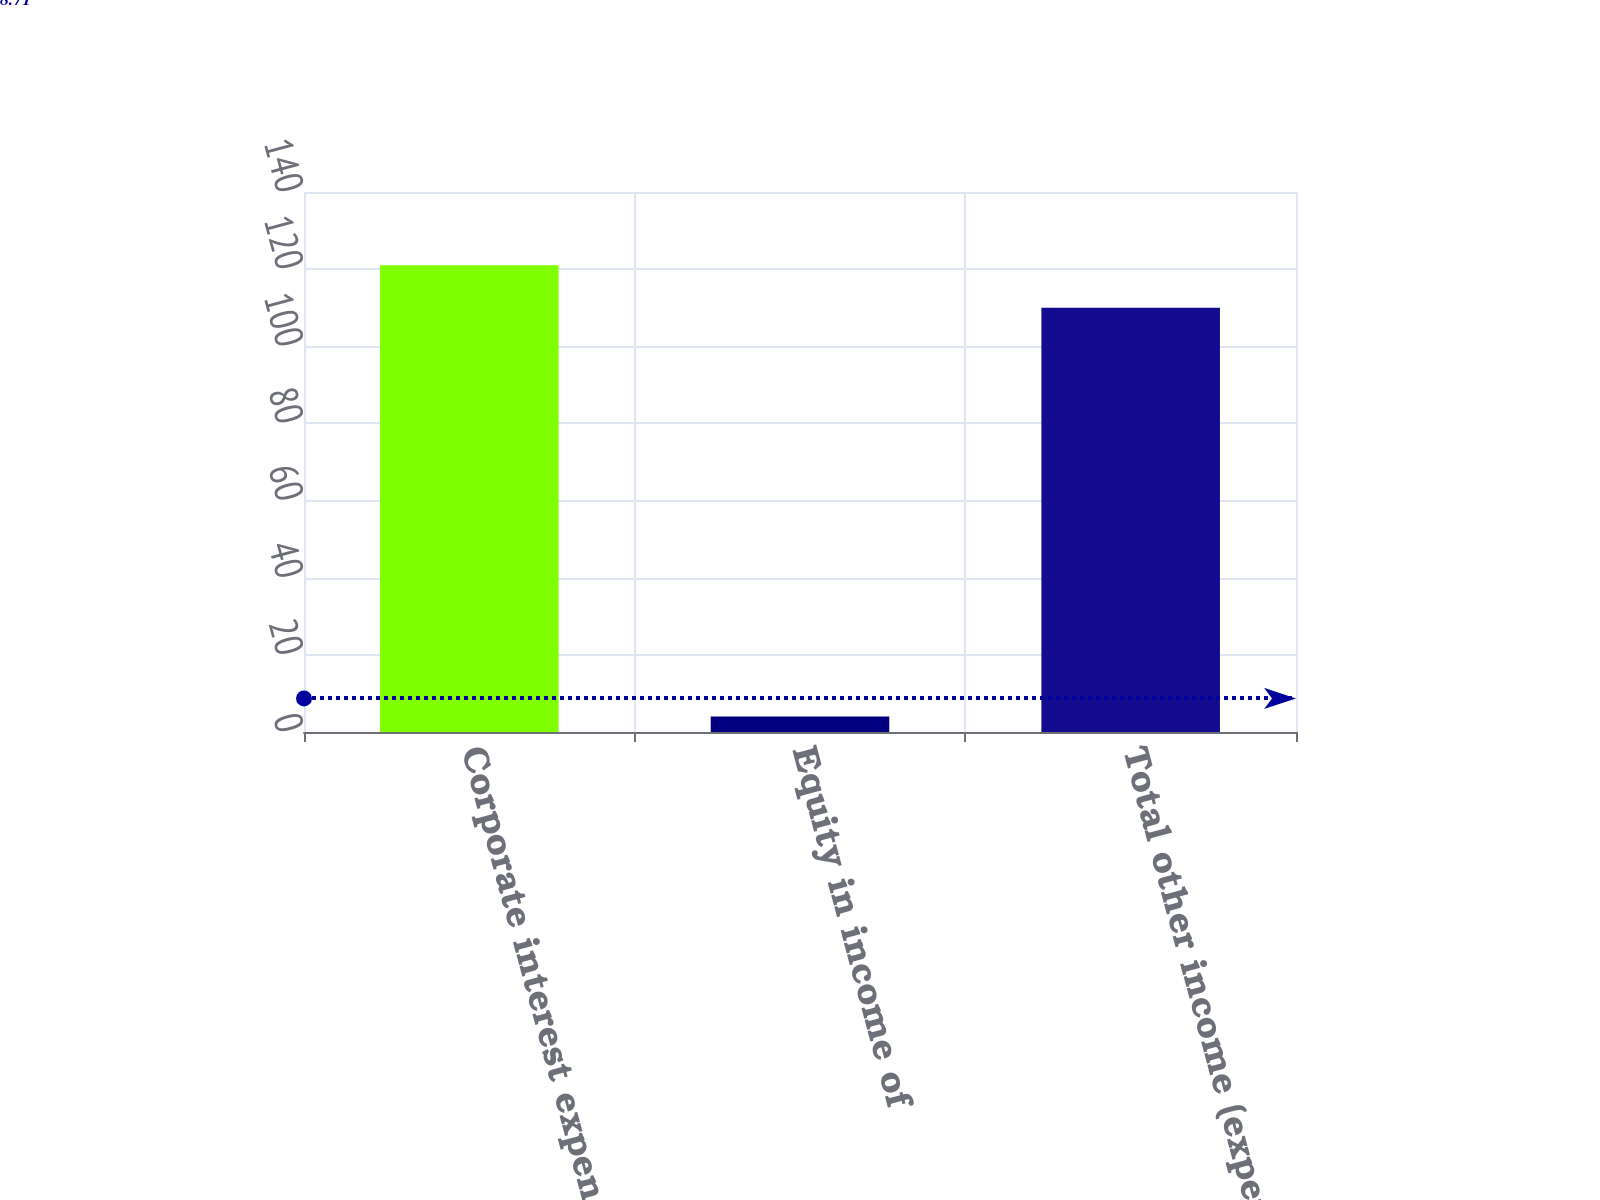<chart> <loc_0><loc_0><loc_500><loc_500><bar_chart><fcel>Corporate interest expense<fcel>Equity in income of<fcel>Total other income (expense)<nl><fcel>121<fcel>4<fcel>110<nl></chart> 